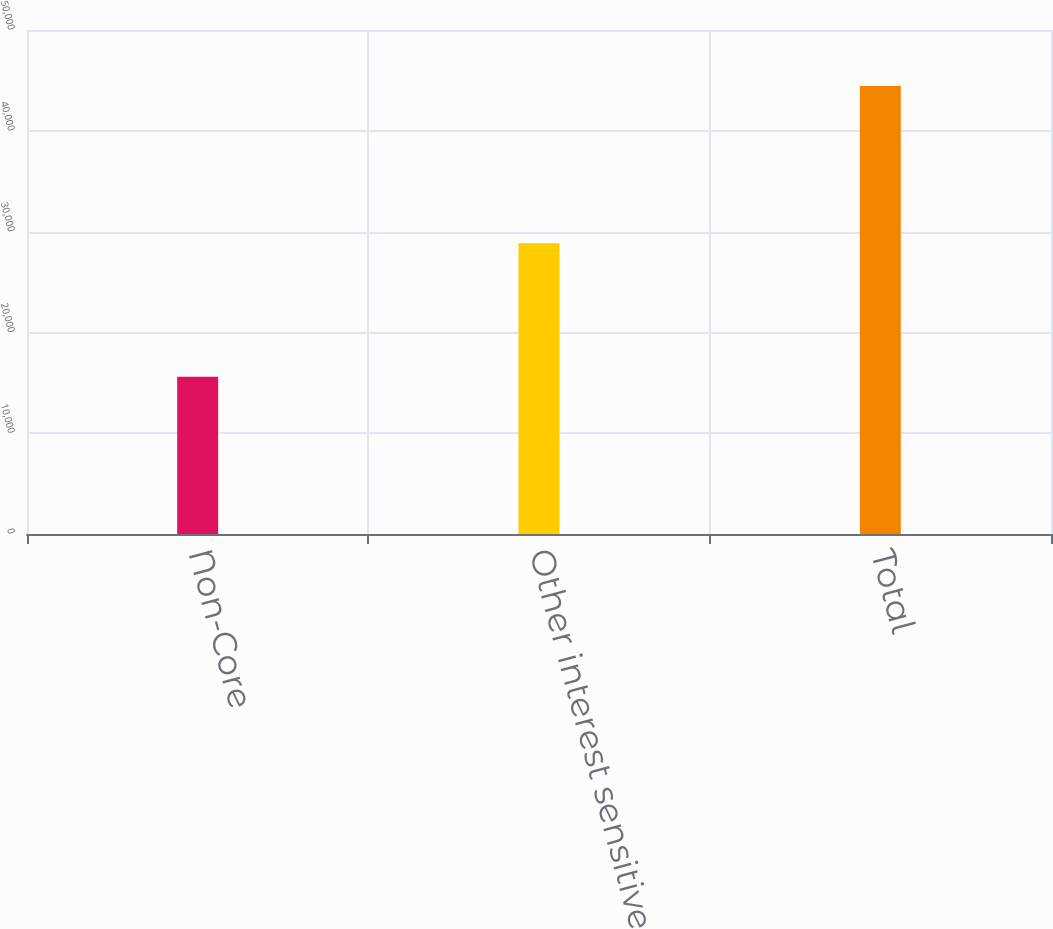Convert chart. <chart><loc_0><loc_0><loc_500><loc_500><bar_chart><fcel>Non-Core<fcel>Other interest sensitive<fcel>Total<nl><fcel>15590<fcel>28855<fcel>44445<nl></chart> 